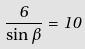<formula> <loc_0><loc_0><loc_500><loc_500>\frac { 6 } { \sin \beta } = 1 0</formula> 